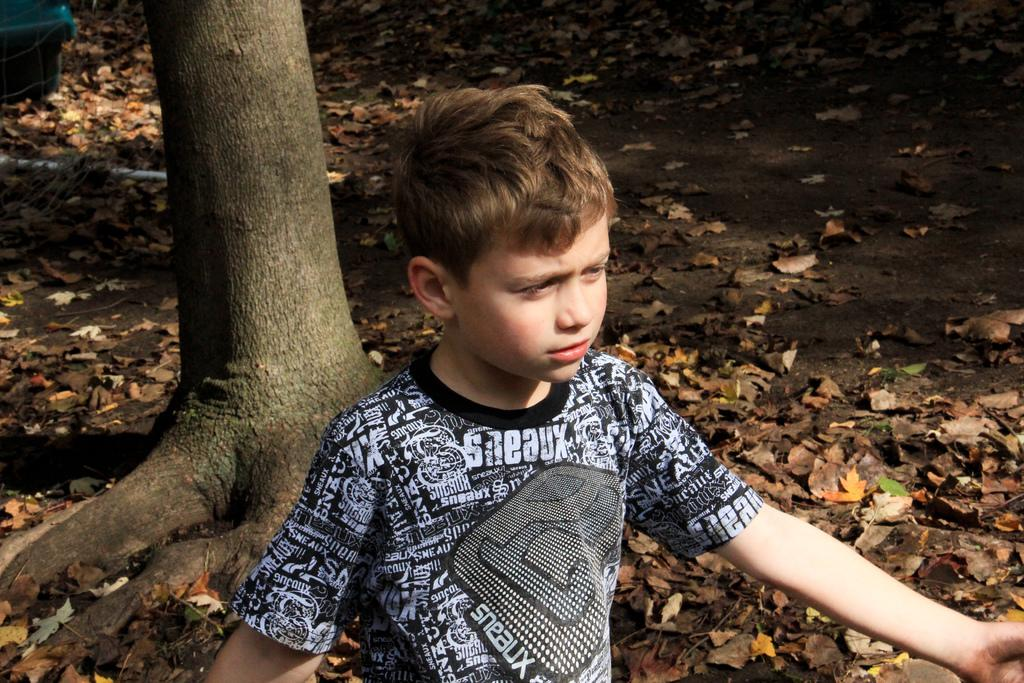What is covering the ground in the image? There are dry leaves on the ground in the image. Who is present in the image? There is a kid at the bottom of the image. What is the kid wearing? The kid is wearing clothes. What can be seen in the middle of the image? There is a stem in the middle of the image. What type of pig can be seen drinking liquid from the window in the image? There is no pig or window present in the image; it features dry leaves on the ground, a kid wearing clothes, and a stem in the middle. 